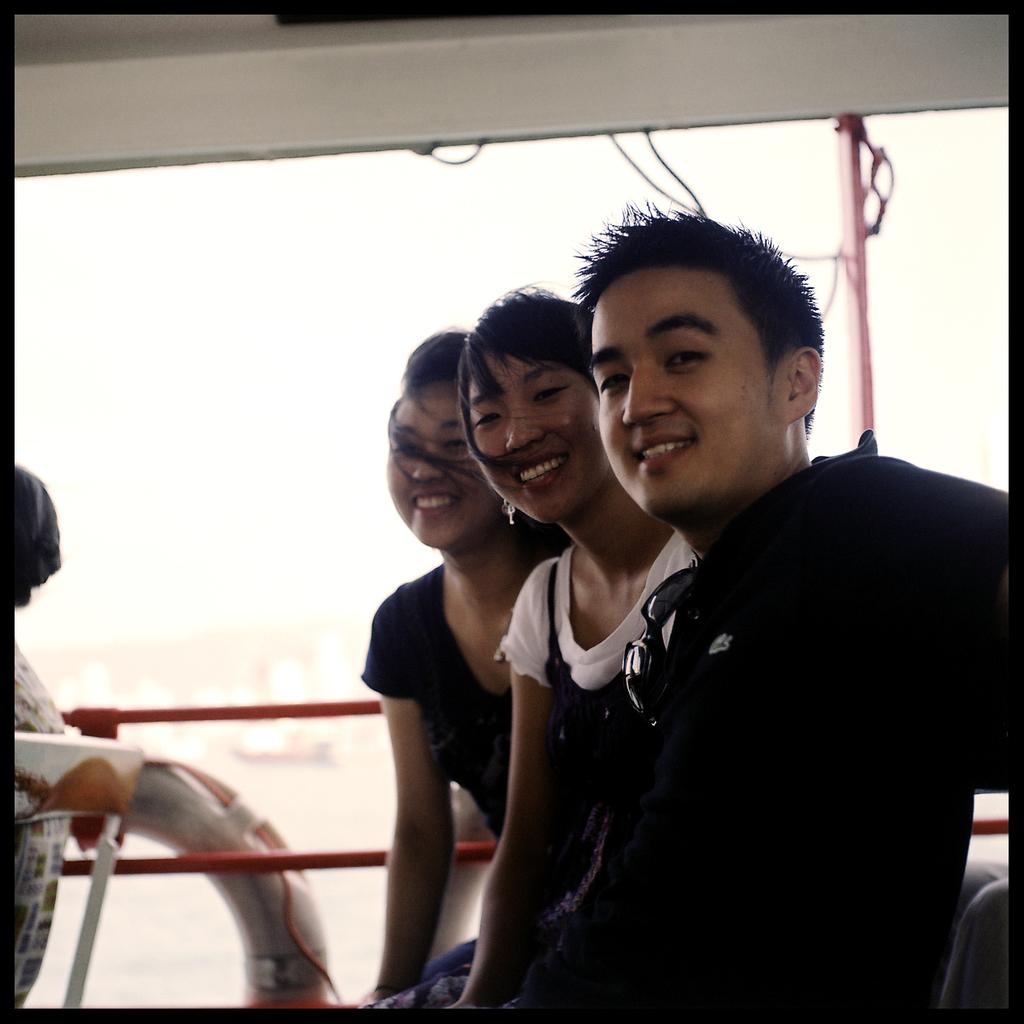What is the main subject of the image? The main subject of the image is a group of people. What colors are the people wearing in the image? The people are wearing white and black color dresses. Where are the people located in the image? The people appear to be sitting on a boat. What is the color of the background in the image? The background of the image is white. How many porters are helping the sisters in the image? There are no porters or sisters present in the image; it features a group of people sitting on a boat. What type of activity are the sisters engaging in with the people in the image? There are no sisters present in the image, and the people are simply sitting on a boat. 